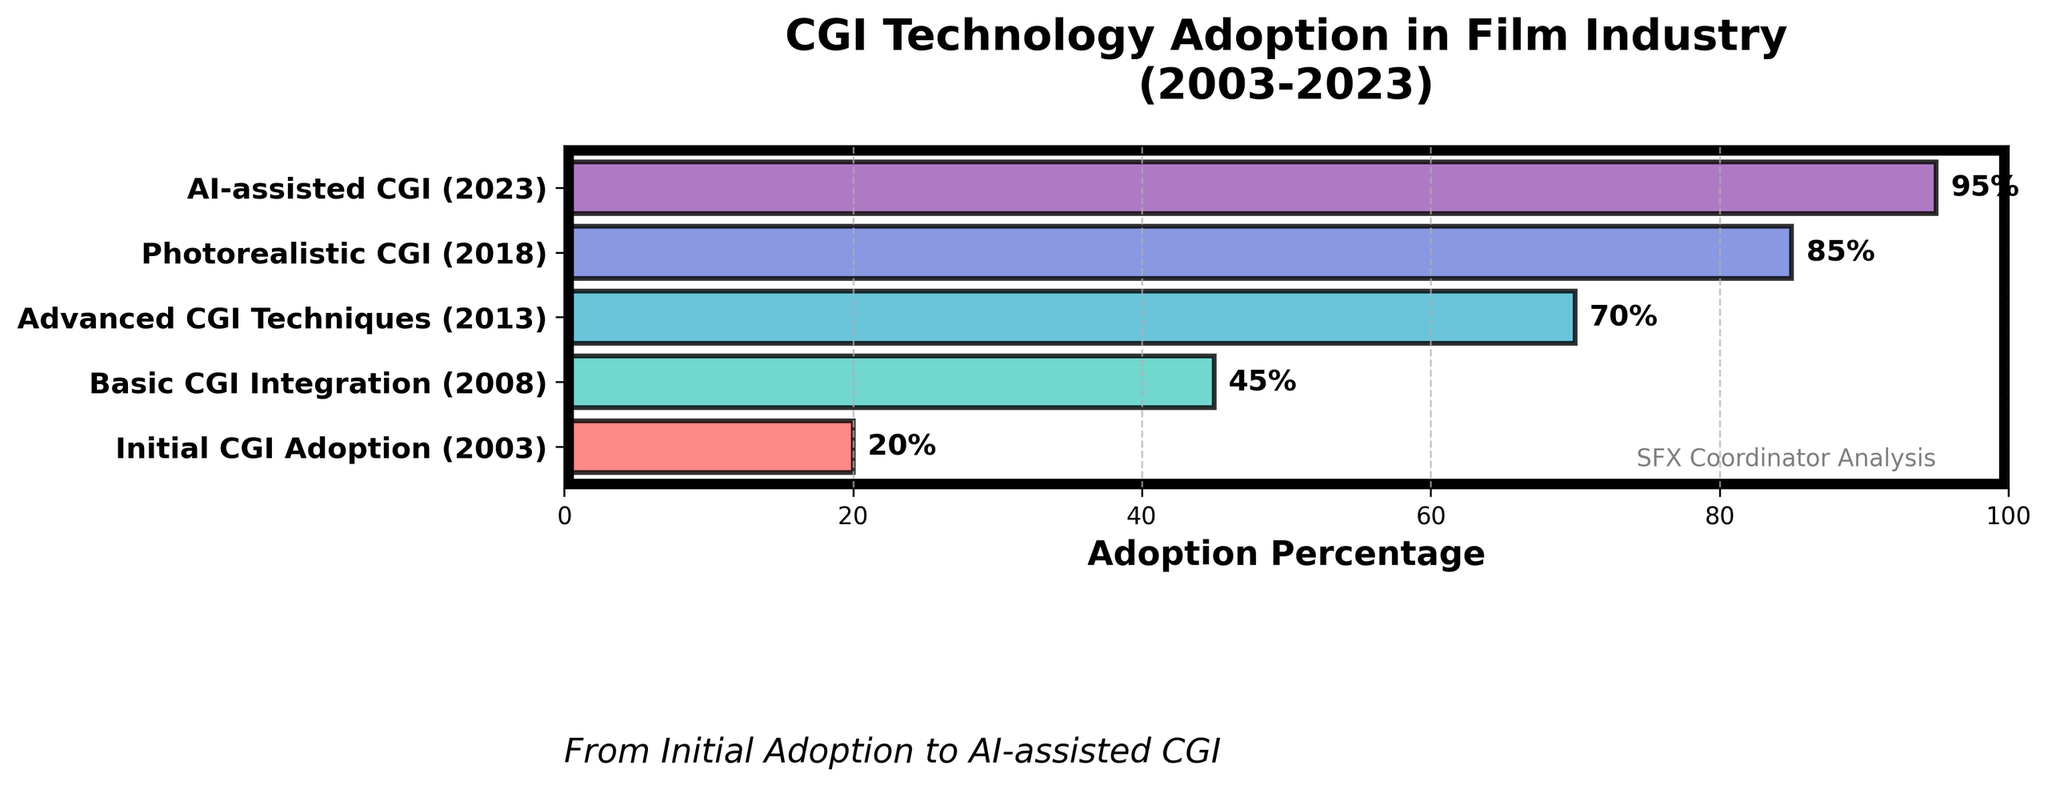Which stage has the highest CGI adoption percentage? The stage with the highest CGI adoption percentage can be identified by looking at the x-axis and finding the largest bar. This stage is 'AI-assisted CGI (2023)' with a percentage of 95%.
Answer: AI-assisted CGI (2023) How many stages are depicted in the funnel chart? The number of stages is indicated by the number of horizontal bars on the chart. By counting the bars, we find there are 5 stages.
Answer: 5 What is the title of the chart? The title of the chart is displayed at the top. The title reads "CGI Technology Adoption in Film Industry (2003-2023)".
Answer: CGI Technology Adoption in Film Industry (2003-2023) How much did the CGI adoption percentage increase from 'Initial CGI Adoption (2003)' to 'Basic CGI Integration (2008)'? To calculate the increase, subtract the percentage at 'Initial CGI Adoption (2003)' (20%) from 'Basic CGI Integration (2008)' (45%). This gives an increase of 25%.
Answer: 25% Which stage has the smallest increase in CGI adoption percentage compared to its preceding stage? By examining the percentages between consecutive stages, we see that the smallest increase is between 'Photorealistic CGI (2018)' (85%) and 'AI-assisted CGI (2023)' (95%), which is a 10% increase.
Answer: AI-assisted CGI (2023) What is the average adoption percentage across all stages? Add all the percentages and divide by the number of stages: (20% + 45% + 70% + 85% + 95%) / 5 = 63%.
Answer: 63% By how much did the adoption percentage increase from 'Advanced CGI Techniques (2013)' to 'Photorealistic CGI (2018)'? Subtract the percentage at 'Advanced CGI Techniques (2013)' (70%) from 'Photorealistic CGI (2018)' (85%), which gives an increase of 15%.
Answer: 15% Which two stages have adoption percentages closest to each other? Compare the differences between consecutive stages. The smallest difference is between 'Photorealistic CGI (2018)' (85%) and 'AI-assisted CGI (2023)' (95%), with a difference of 10%.
Answer: Photorealistic CGI (2018) and AI-assisted CGI (2023) What is the percentage increase from the first stage to the last stage? Subtract the percentage at 'Initial CGI Adoption (2003)' (20%) from 'AI-assisted CGI (2023)' (95%) to find the total increase over the two decades, which is 75%.
Answer: 75% Which stage marks the halfway point in terms of adoption percentage? The halfway point in terms of adoption percentage is closest to 50%. 'Basic CGI Integration (2008)', with 45%, is the stage closest to this midpoint.
Answer: Basic CGI Integration (2008) 